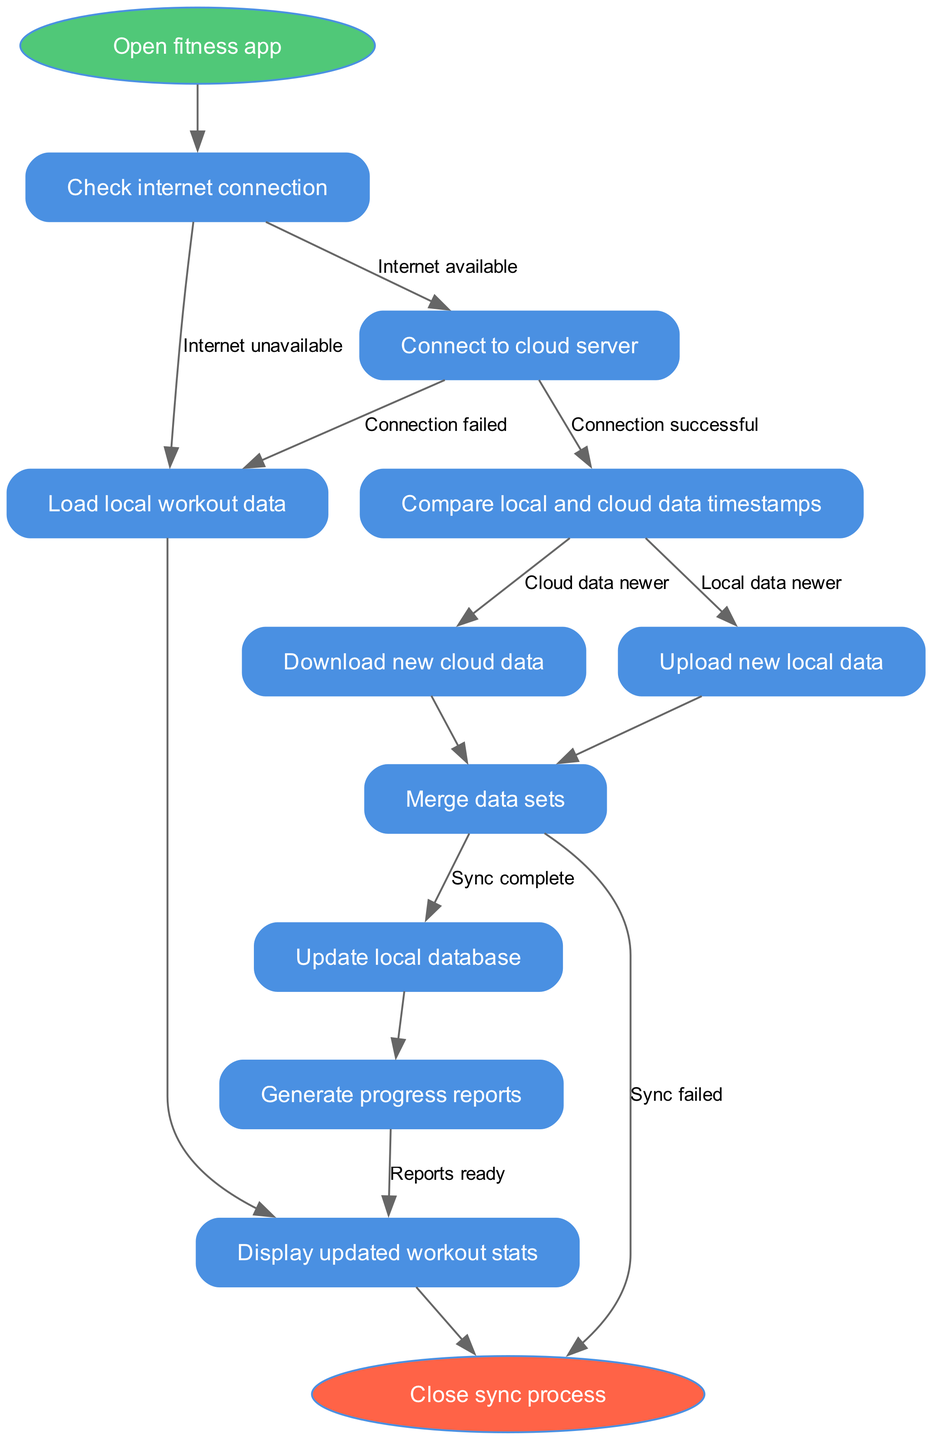What is the starting point of the data synchronization process? The starting point is clearly indicated as "Open fitness app," which is represented as the first node in the flow chart.
Answer: Open fitness app How many nodes are present in the diagram? The nodes in the diagram are: "Open fitness app," "Check internet connection," "Load local workout data," "Connect to cloud server," "Compare local and cloud data timestamps," "Upload new local data," "Download new cloud data," "Merge data sets," "Update local database," "Generate progress reports," and "Display updated workout stats." This totals to 11 nodes.
Answer: 11 What happens if the internet is unavailable? In this scenario, the flow chart leads directly from "Check internet connection" to "Load local workout data," indicating that if the internet is unavailable, the user can still load their local data without syncing.
Answer: Load local workout data What is the end node of the synchronization process? The end node is labeled "Close sync process," which marks the completion of the data synchronization flow.
Answer: Close sync process What is the relationship between "Connect to cloud server" and "Compare local and cloud data timestamps"? After successfully connecting to the cloud server (labelled as "Connection successful"), the next step in the flow chart is to "Compare local and cloud data timestamps," which indicates a sequential flow from one process to the next.
Answer: Sequential What occurs when both local data and cloud data are newer? The flow chart provides options to handle older data: if local data is newer, it moves on to upload new local data; if cloud data is newer, it will download new cloud data. Therefore, it directly guides the user to data synchronization based on the most recent data.
Answer: Merge data sets What happens after "Generate progress reports"? Following "Generate progress reports," the flow chart indicates movement to "Display updated workout stats," showing how progress is visually presented to the user.
Answer: Display updated workout stats How does the process conclude if data synchronization fails? The diagram indicates that if the synchronization fails, the process leads directly to the end node "Close sync process," showing that the operation will end without success.
Answer: Close sync process What edge indicates a successful connection to the cloud server? The successful connection to the cloud server is indicated by the edge labeled "Connection successful," which transitions the process to the next step in the synchronization workflow.
Answer: Connection successful 